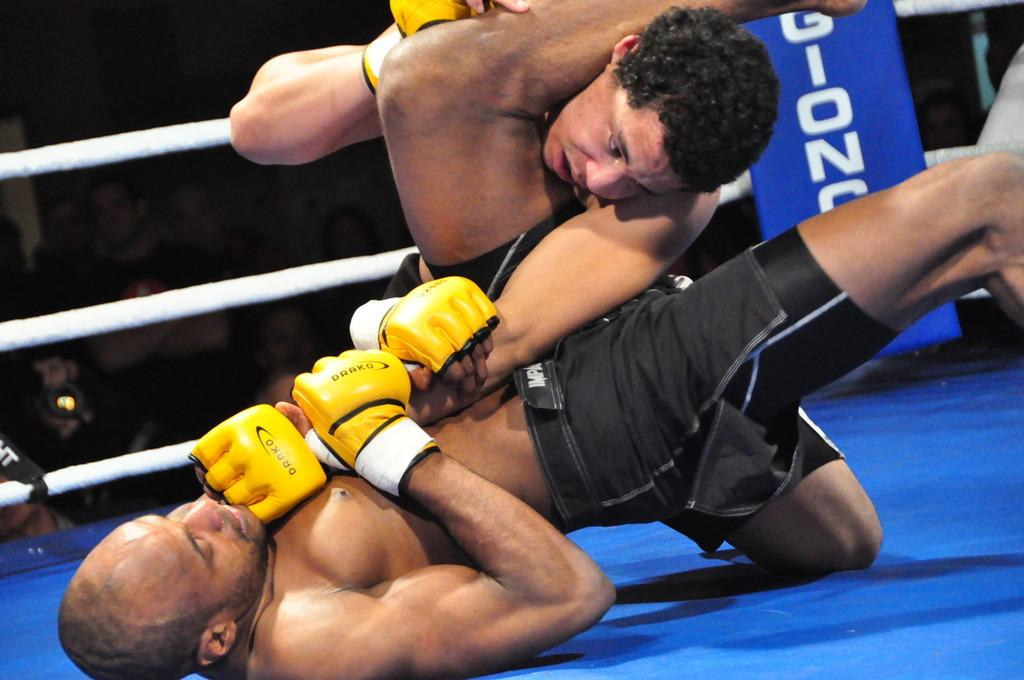<image>
Relay a brief, clear account of the picture shown. a yellow glove with the word darko on it 